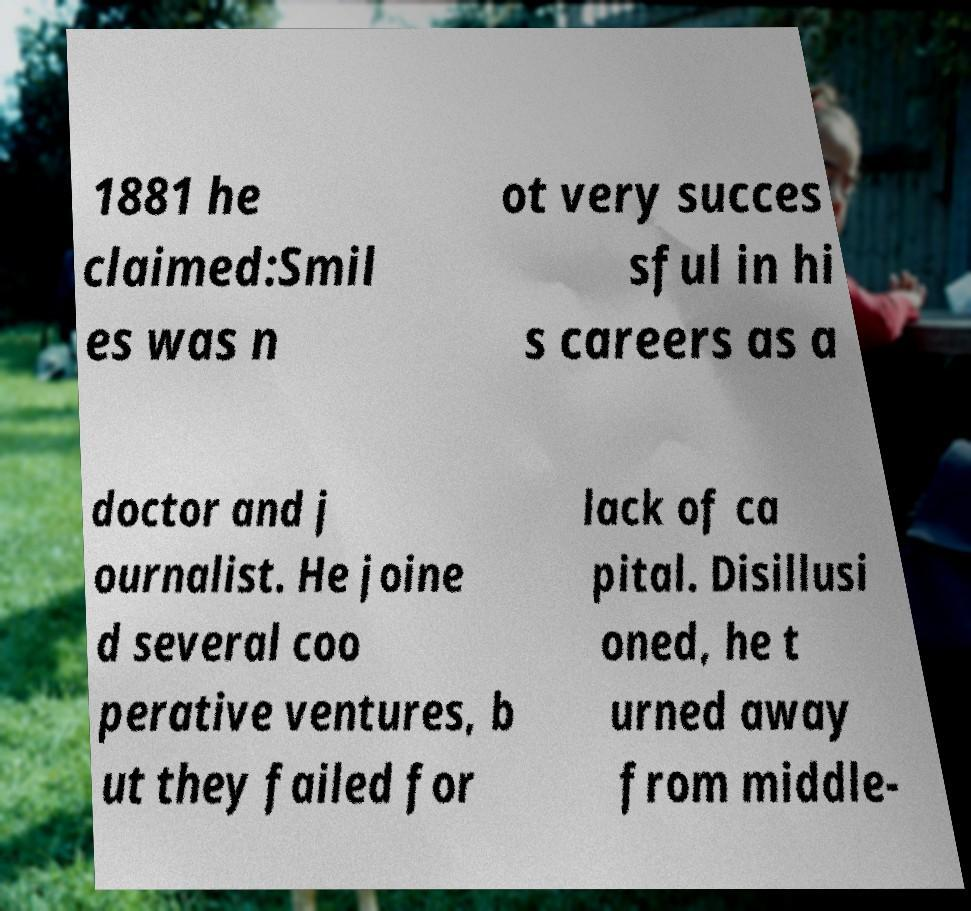Could you extract and type out the text from this image? 1881 he claimed:Smil es was n ot very succes sful in hi s careers as a doctor and j ournalist. He joine d several coo perative ventures, b ut they failed for lack of ca pital. Disillusi oned, he t urned away from middle- 